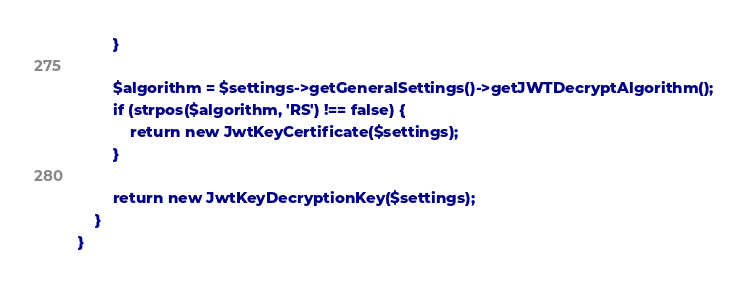<code> <loc_0><loc_0><loc_500><loc_500><_PHP_>        }

        $algorithm = $settings->getGeneralSettings()->getJWTDecryptAlgorithm();
        if (strpos($algorithm, 'RS') !== false) {
            return new JwtKeyCertificate($settings);
        }

        return new JwtKeyDecryptionKey($settings);
    }
}
</code> 